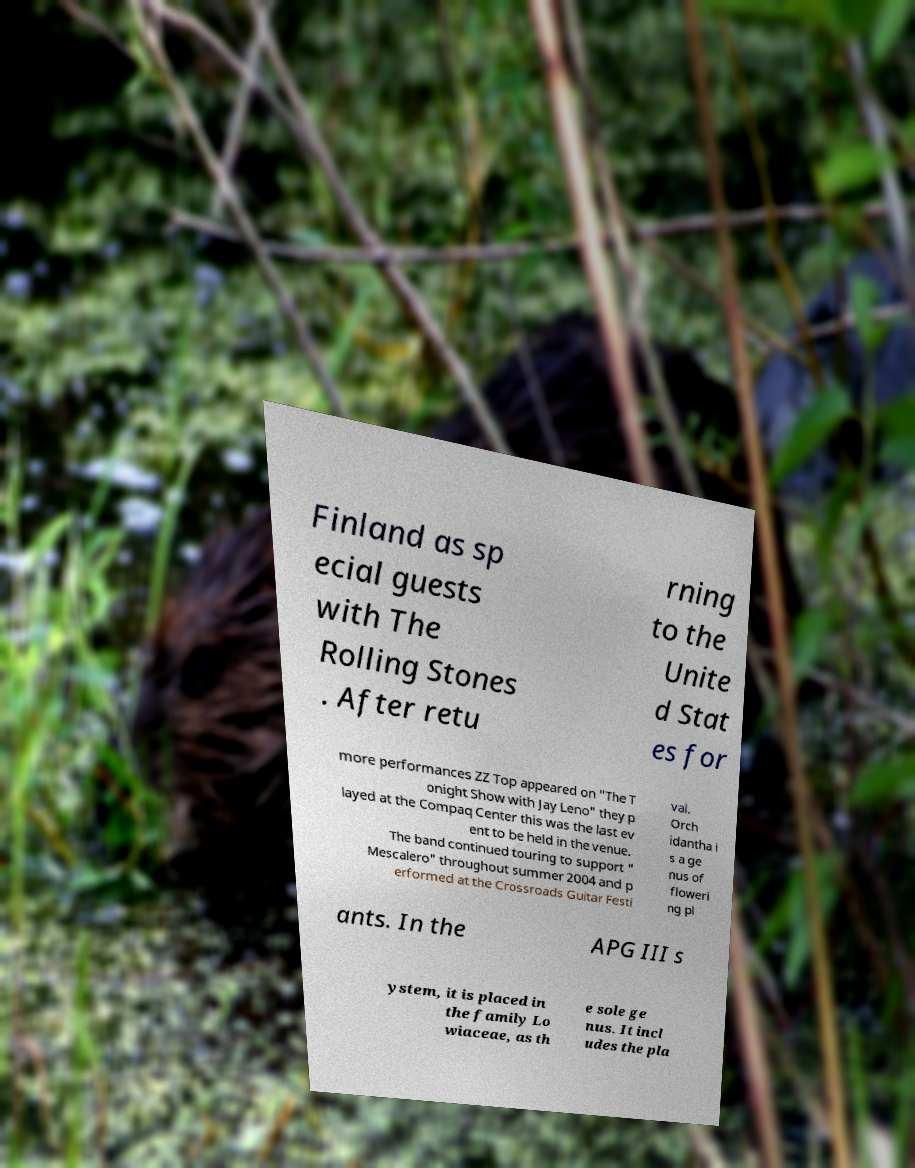Can you read and provide the text displayed in the image?This photo seems to have some interesting text. Can you extract and type it out for me? Finland as sp ecial guests with The Rolling Stones . After retu rning to the Unite d Stat es for more performances ZZ Top appeared on "The T onight Show with Jay Leno" they p layed at the Compaq Center this was the last ev ent to be held in the venue. The band continued touring to support " Mescalero" throughout summer 2004 and p erformed at the Crossroads Guitar Festi val. Orch idantha i s a ge nus of floweri ng pl ants. In the APG III s ystem, it is placed in the family Lo wiaceae, as th e sole ge nus. It incl udes the pla 